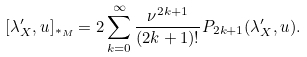Convert formula to latex. <formula><loc_0><loc_0><loc_500><loc_500>[ \lambda ^ { \prime } _ { X } , u ] _ { \ast _ { M } } = 2 \sum _ { k = 0 } ^ { \infty } \frac { \nu ^ { 2 k + 1 } } { ( 2 k + 1 ) ! } P _ { 2 k + 1 } ( \lambda ^ { \prime } _ { X } , u ) .</formula> 